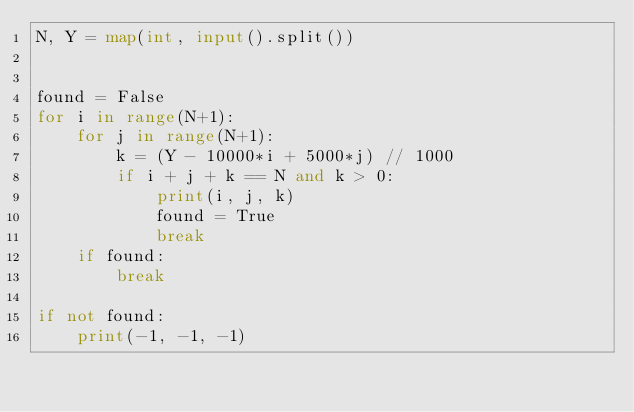<code> <loc_0><loc_0><loc_500><loc_500><_Python_>N, Y = map(int, input().split())


found = False
for i in range(N+1):
    for j in range(N+1):
        k = (Y - 10000*i + 5000*j) // 1000
        if i + j + k == N and k > 0:
            print(i, j, k)
            found = True
            break
    if found:
        break

if not found:
    print(-1, -1, -1)</code> 